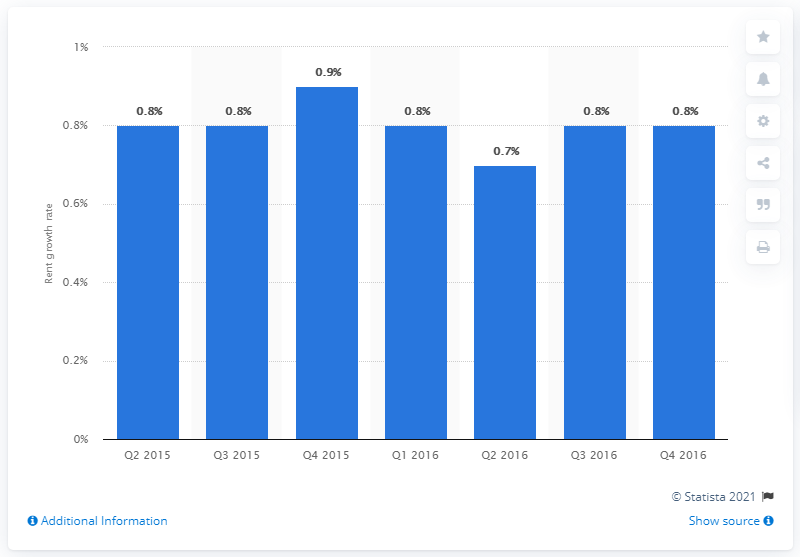Identify some key points in this picture. The expected amount of industrial rent growth in the fourth quarter of 2016 was 0.8%. 